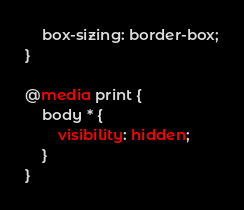<code> <loc_0><loc_0><loc_500><loc_500><_CSS_>	box-sizing: border-box;
}

@media print {
	body * {
		visibility: hidden;
	}
}
</code> 